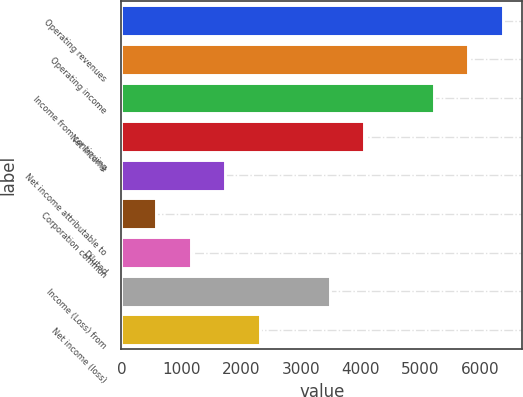Convert chart to OTSL. <chart><loc_0><loc_0><loc_500><loc_500><bar_chart><fcel>Operating revenues<fcel>Operating income<fcel>Income from continuing<fcel>Net income<fcel>Net income attributable to<fcel>Corporation common<fcel>Diluted<fcel>Income (Loss) from<fcel>Net income (loss)<nl><fcel>6378.77<fcel>5798.96<fcel>5219.15<fcel>4059.53<fcel>1740.29<fcel>580.67<fcel>1160.48<fcel>3479.72<fcel>2320.1<nl></chart> 